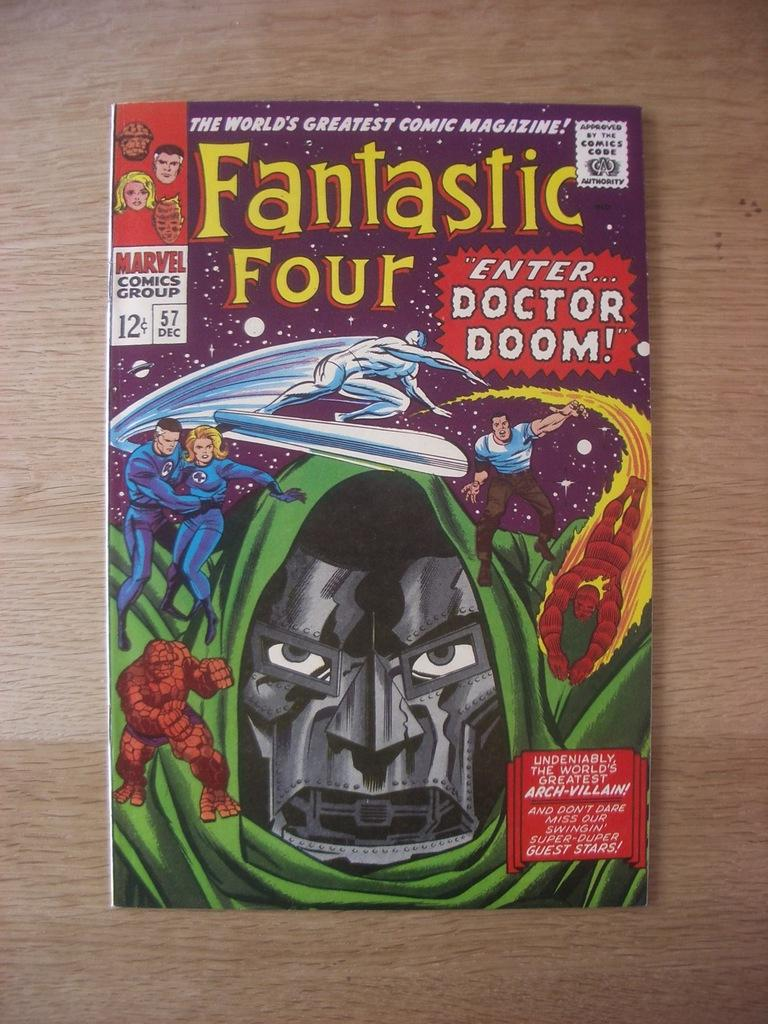What is the main object in the image? There is a book in the image. What is the book placed on? The book is on a wooden surface. What can be seen on the book cover? The book cover has animated pictures of people and printed text. Can you see any farmers working on the mountain in the image? There is no mountain or farmer present in the image; it features a book with an animated book cover. What type of apparatus is used to read the book in the image? There is no apparatus mentioned or visible in the image; the book is simply placed on a wooden surface. 